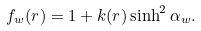<formula> <loc_0><loc_0><loc_500><loc_500>f _ { w } ( r ) = 1 + k ( r ) \sinh ^ { 2 } \alpha _ { w } .</formula> 